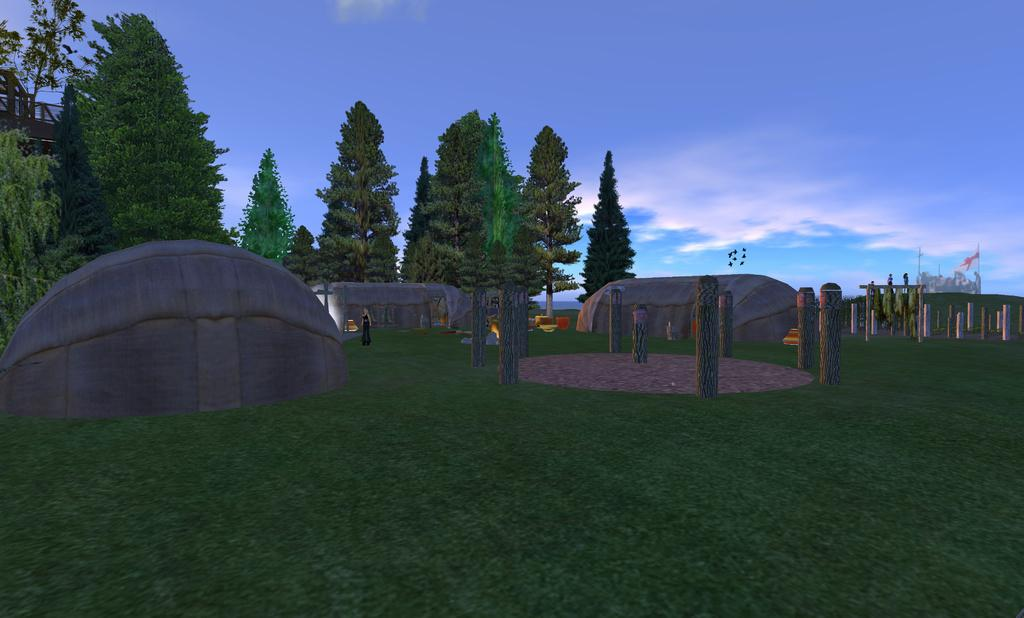What type of image is in the picture? There is a graphical image in the picture. What natural elements can be seen in the image? There are stones in the image. What man-made structures are present in the image? There are poles in the image. What is the person in the image doing? There is a person on the ground in the image. What can be seen in the background of the image? There is a flag and the sky visible in the background of the image. How does the person in the image apply the brake while standing on the ground? There is no brake present in the image, and the person is not shown applying any brakes. What type of test is being conducted in the image? There is no indication of a test being conducted in the image. 